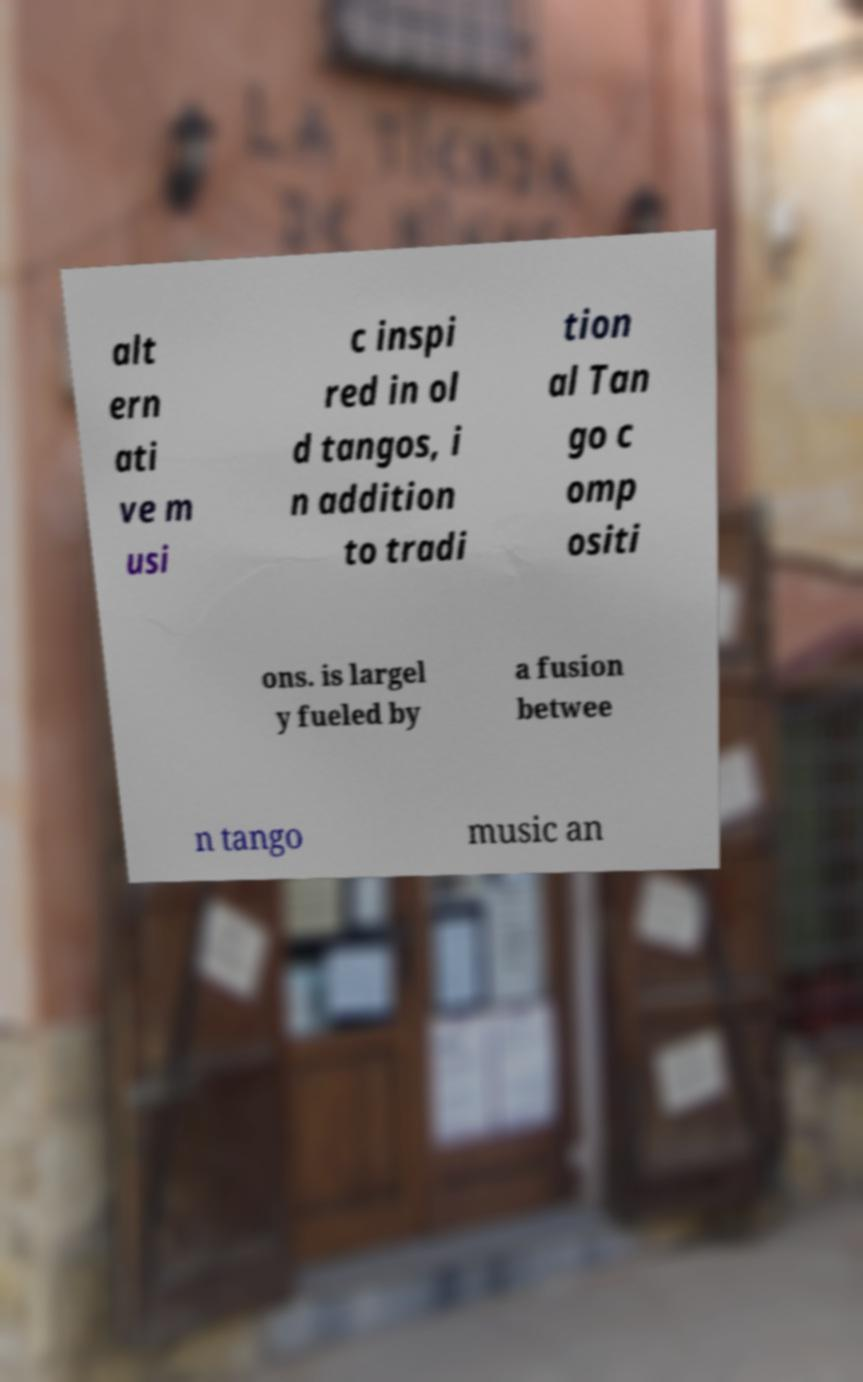For documentation purposes, I need the text within this image transcribed. Could you provide that? alt ern ati ve m usi c inspi red in ol d tangos, i n addition to tradi tion al Tan go c omp ositi ons. is largel y fueled by a fusion betwee n tango music an 